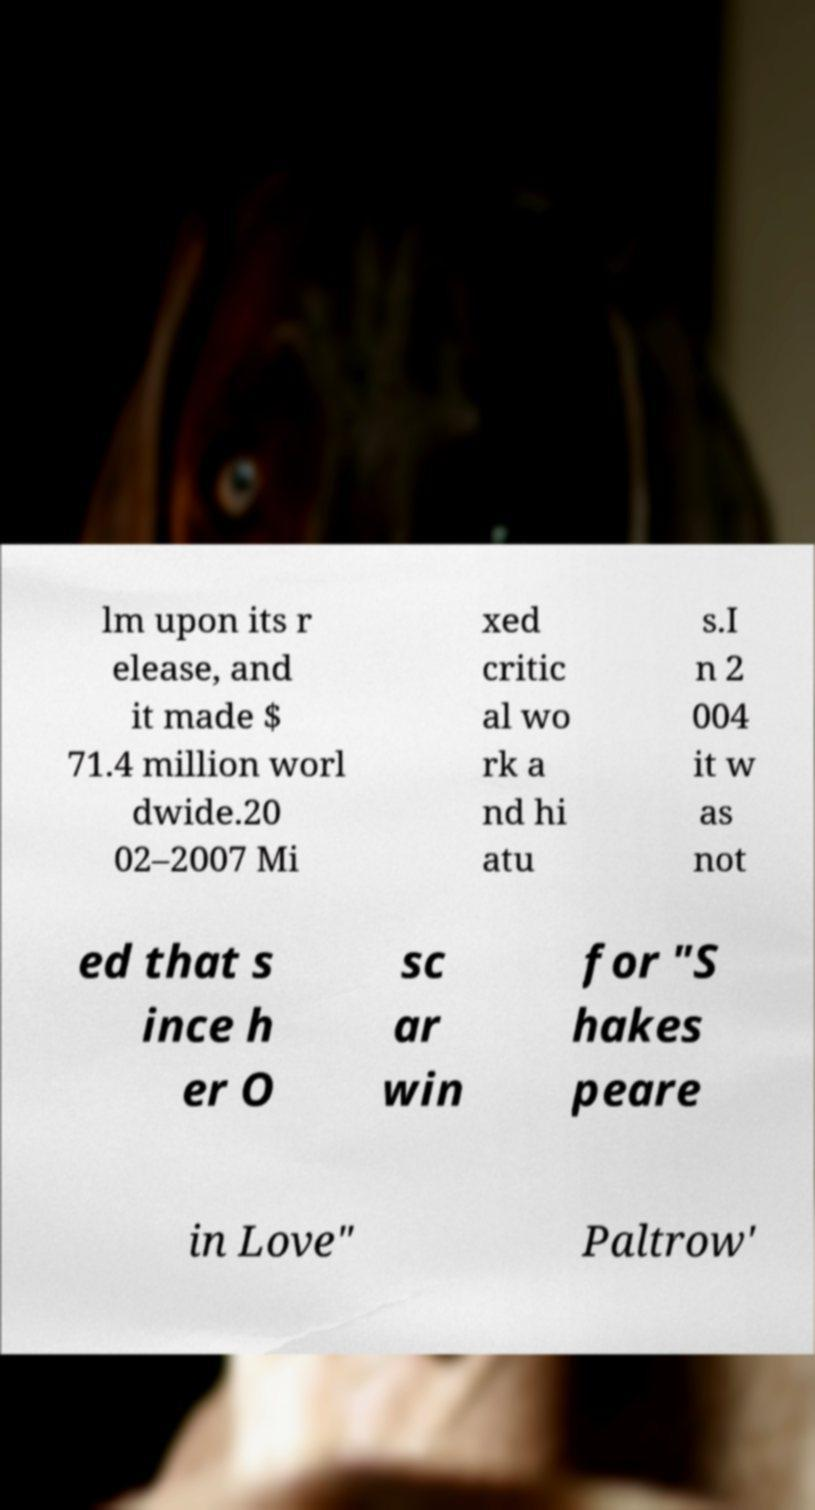Please identify and transcribe the text found in this image. lm upon its r elease, and it made $ 71.4 million worl dwide.20 02–2007 Mi xed critic al wo rk a nd hi atu s.I n 2 004 it w as not ed that s ince h er O sc ar win for "S hakes peare in Love" Paltrow' 